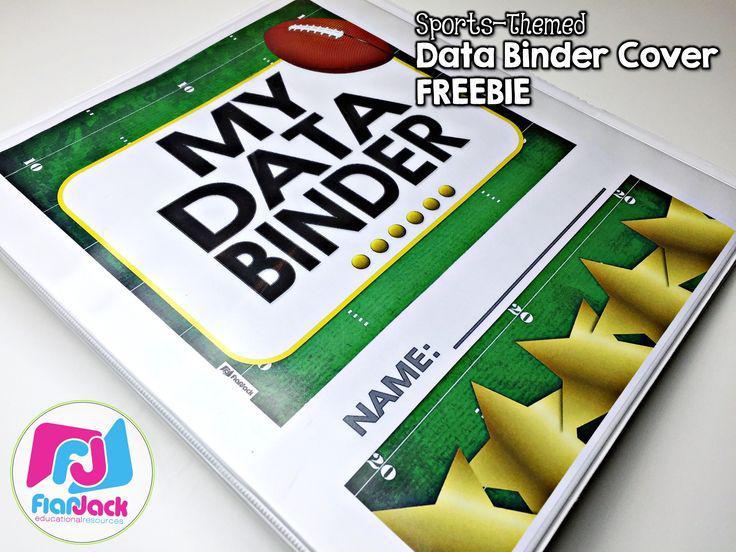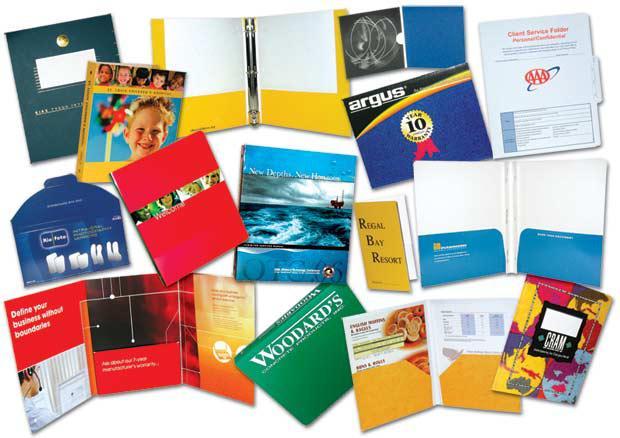The first image is the image on the left, the second image is the image on the right. Considering the images on both sides, is "A person is gripping multiple different colored binders in one of the images." valid? Answer yes or no. No. The first image is the image on the left, the second image is the image on the right. For the images displayed, is the sentence "There is a woman in the image on the right." factually correct? Answer yes or no. No. 